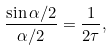<formula> <loc_0><loc_0><loc_500><loc_500>\frac { \sin \alpha / 2 } { \alpha / 2 } = \frac { 1 } { 2 \tau } ,</formula> 